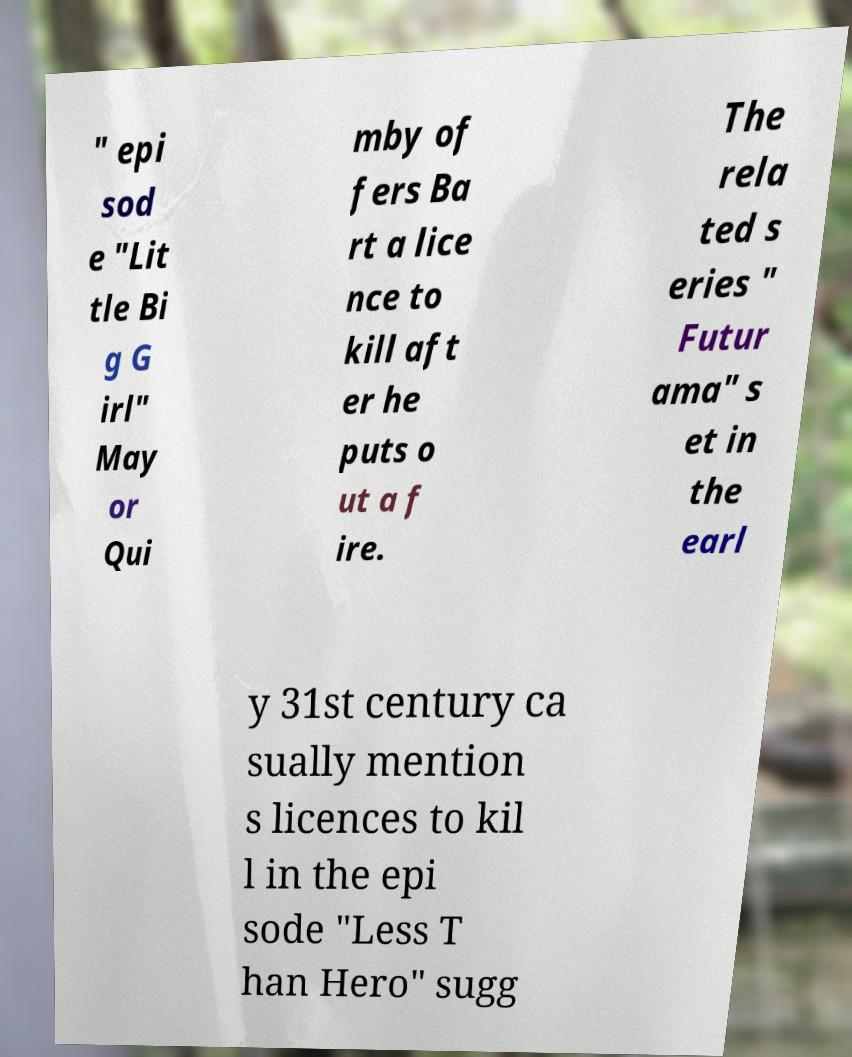Please read and relay the text visible in this image. What does it say? " epi sod e "Lit tle Bi g G irl" May or Qui mby of fers Ba rt a lice nce to kill aft er he puts o ut a f ire. The rela ted s eries " Futur ama" s et in the earl y 31st century ca sually mention s licences to kil l in the epi sode "Less T han Hero" sugg 